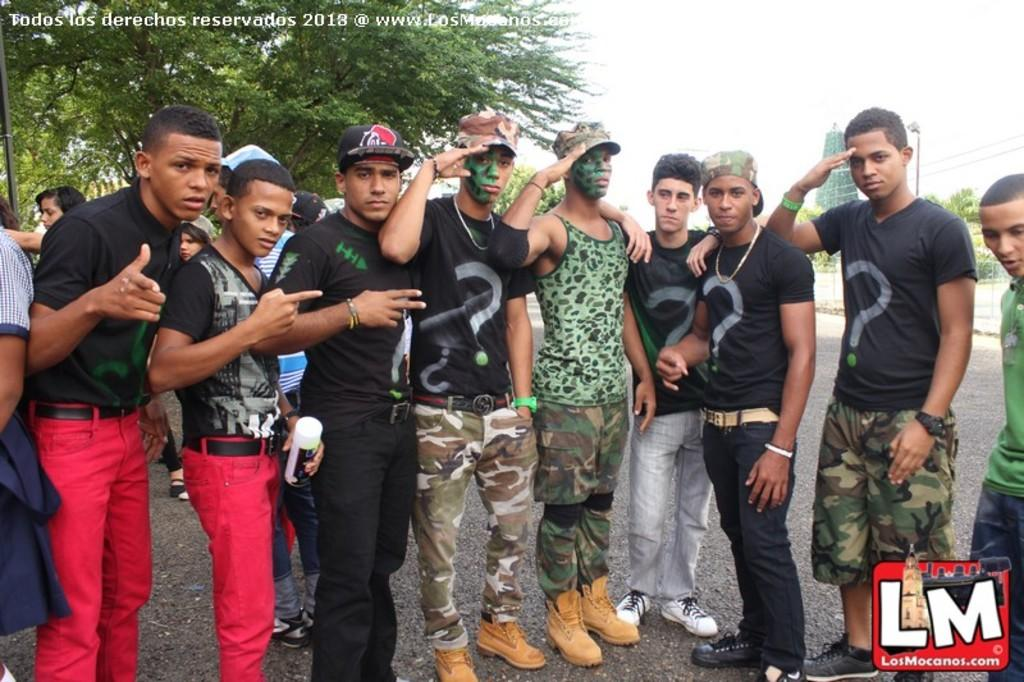How many people are in the image? There is a group of people in the image, but the exact number cannot be determined from the provided facts. What is the position of the people in the image? The people are standing on the ground in the image. What type of vegetation is present in the image? There is a tree in the image. What structures can be seen in the image? There are poles in the image. What type of arch can be seen in the image? There is no arch present in the image. What kind of plants are growing near the poles in the image? The provided facts do not mention any plants near the poles in the image. 